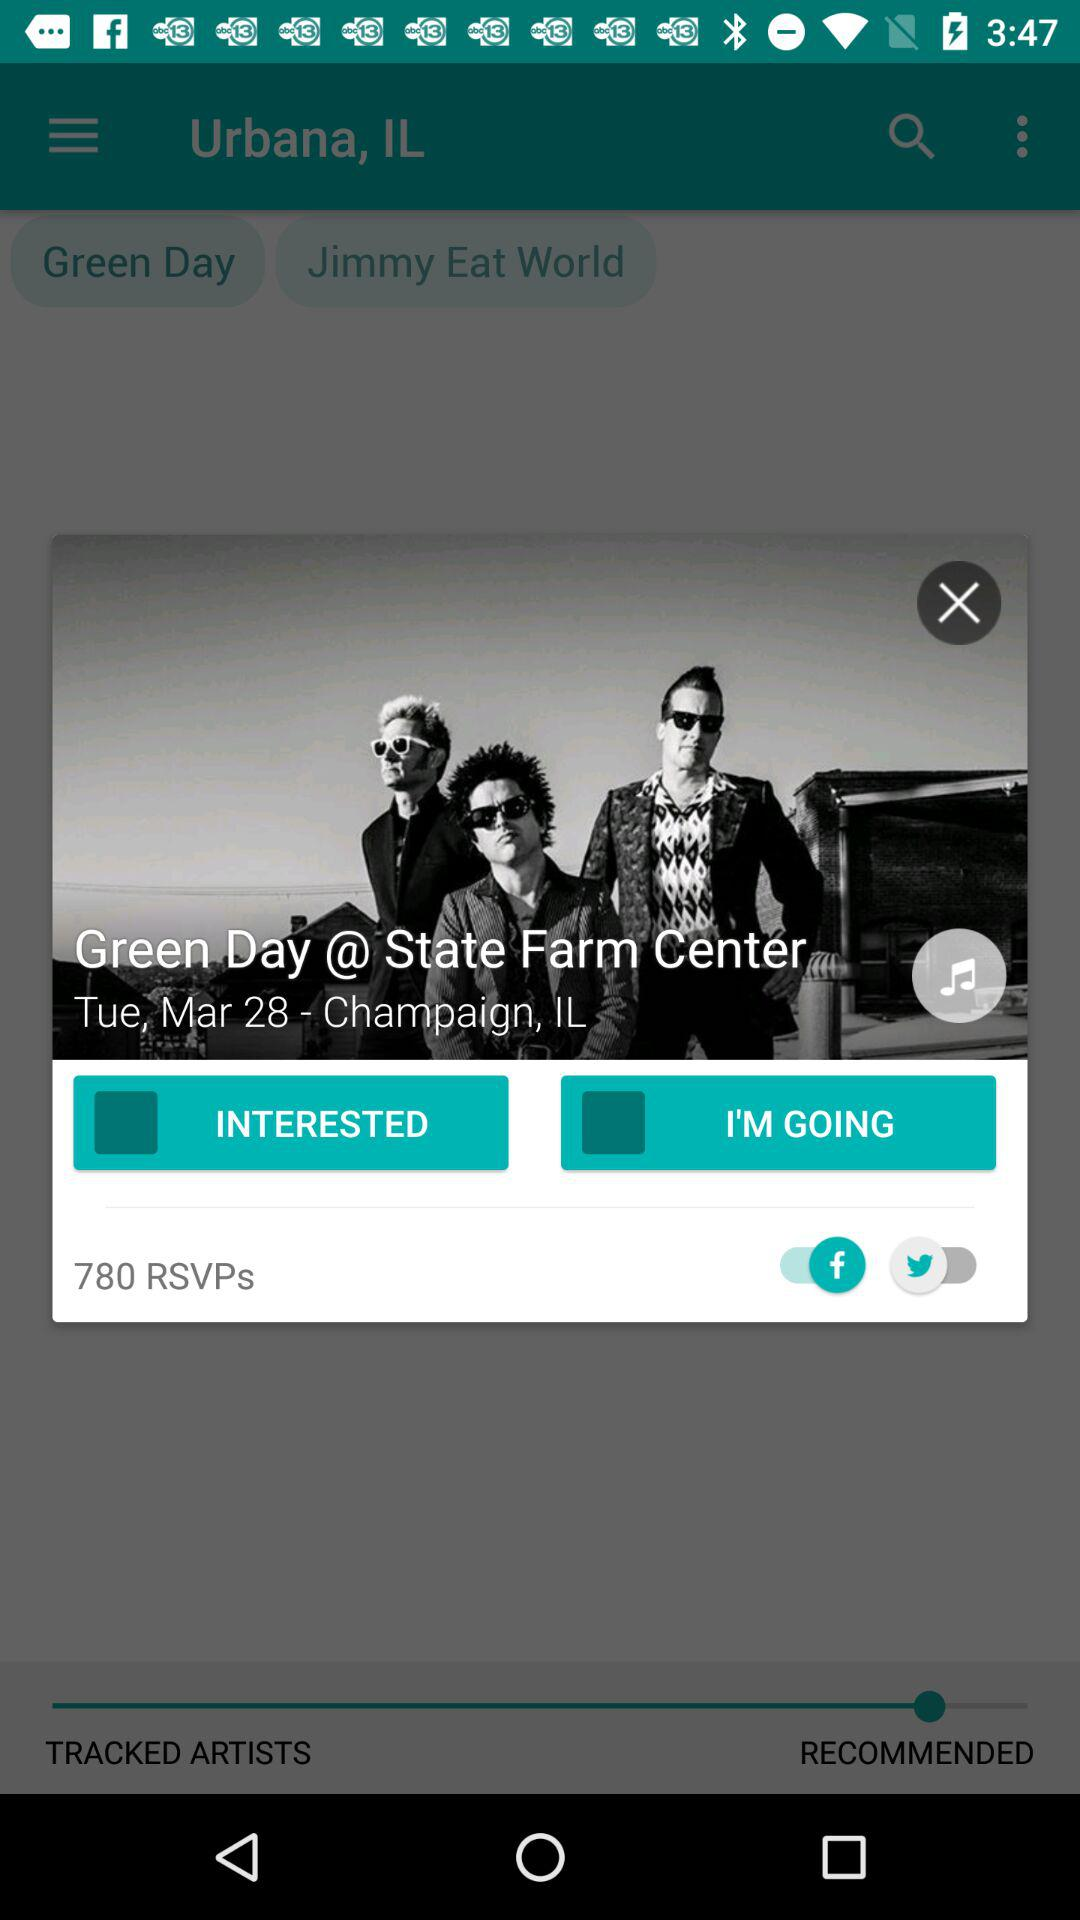What is the status of "INTERESTED"? The status is "off". 